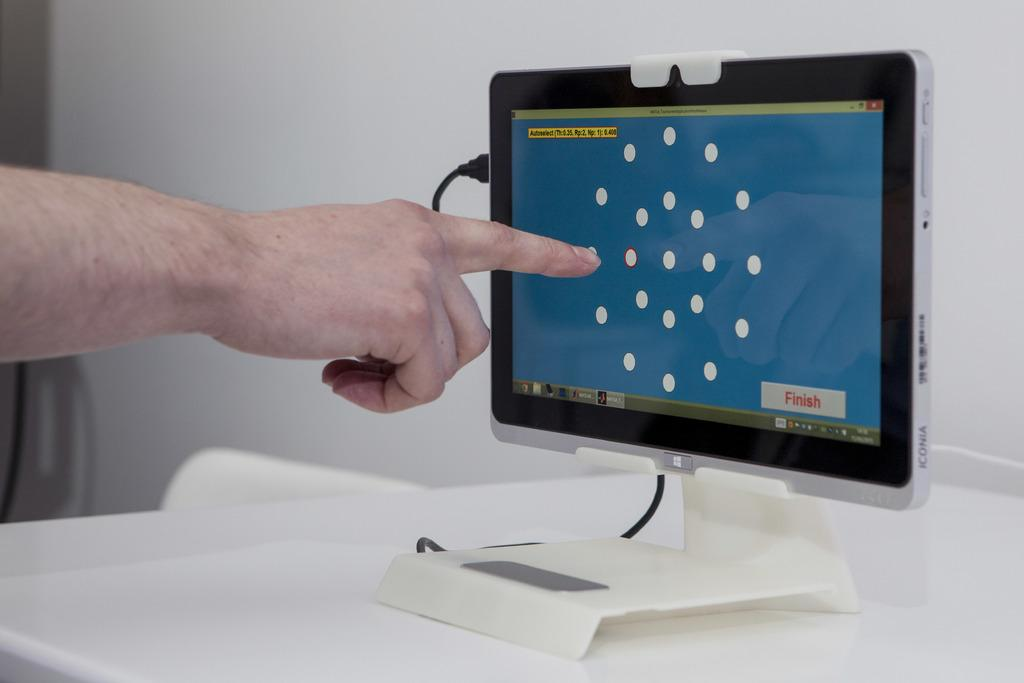What is the main object in the image? There is a table in the image. What is on the table? There is a tab with a cable on the table. What is the person in the image doing? The person is pointing at a screen. What type of pain is the person experiencing in the image? There is no indication of pain in the image; the person is pointing at a screen. What is inside the box on the table? There is no box present on the table in the image. 